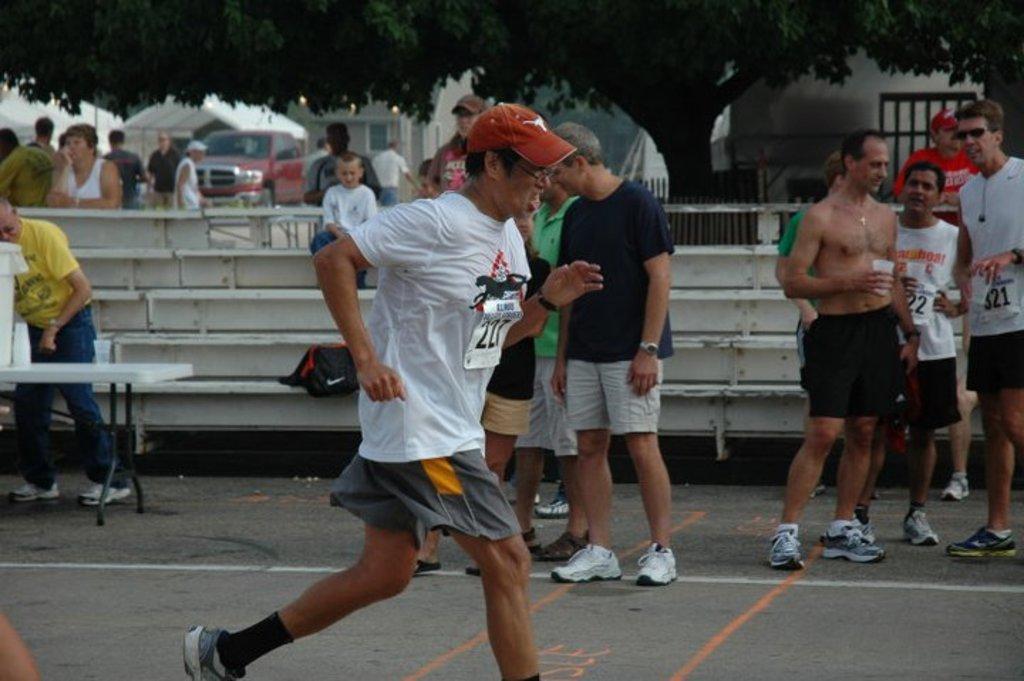How would you summarize this image in a sentence or two? In this picture I can see in the middle a man is running and a group of people are standing, in the background there are trees and buildings. On the left side there is a vehicle. 